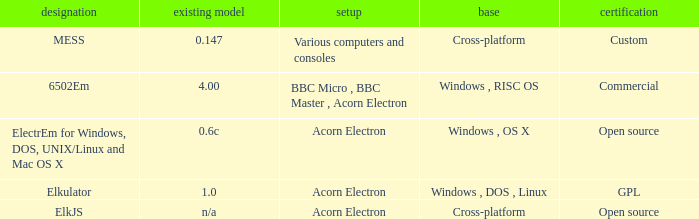What is the name of the platform used for various computers and consoles? Cross-platform. 